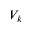Convert formula to latex. <formula><loc_0><loc_0><loc_500><loc_500>V _ { k }</formula> 